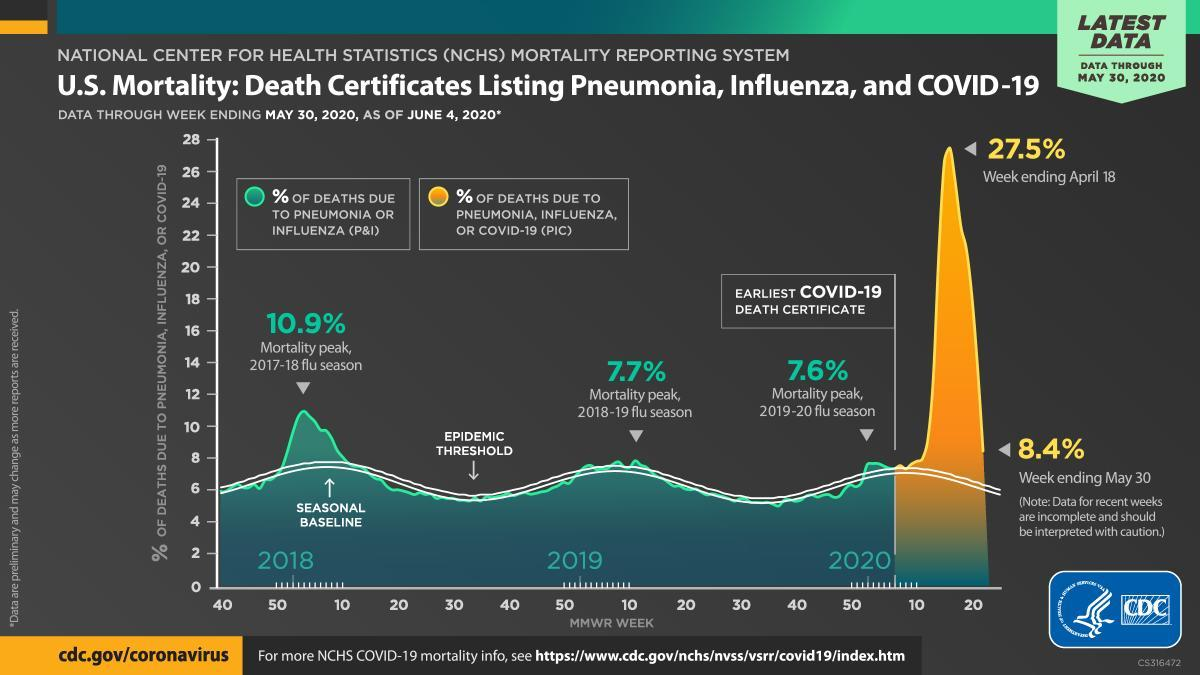In which month was the COVID-19 related death the highest
Answer the question with a short phrase. April From which year did the COVID-19 death start getting recorded 2020 What has been the highest mortality peak in 2019 due to pneumonia or influenza 7.7% What has been the highest mortality peak in 2018 due to pneumonia or influenza 10.9% 